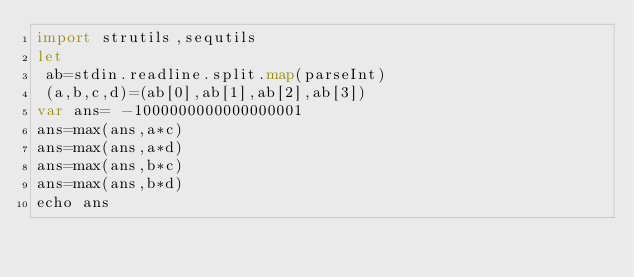Convert code to text. <code><loc_0><loc_0><loc_500><loc_500><_Nim_>import strutils,sequtils
let
 ab=stdin.readline.split.map(parseInt)
 (a,b,c,d)=(ab[0],ab[1],ab[2],ab[3])
var ans= -1000000000000000001
ans=max(ans,a*c)
ans=max(ans,a*d)
ans=max(ans,b*c)
ans=max(ans,b*d)
echo ans</code> 